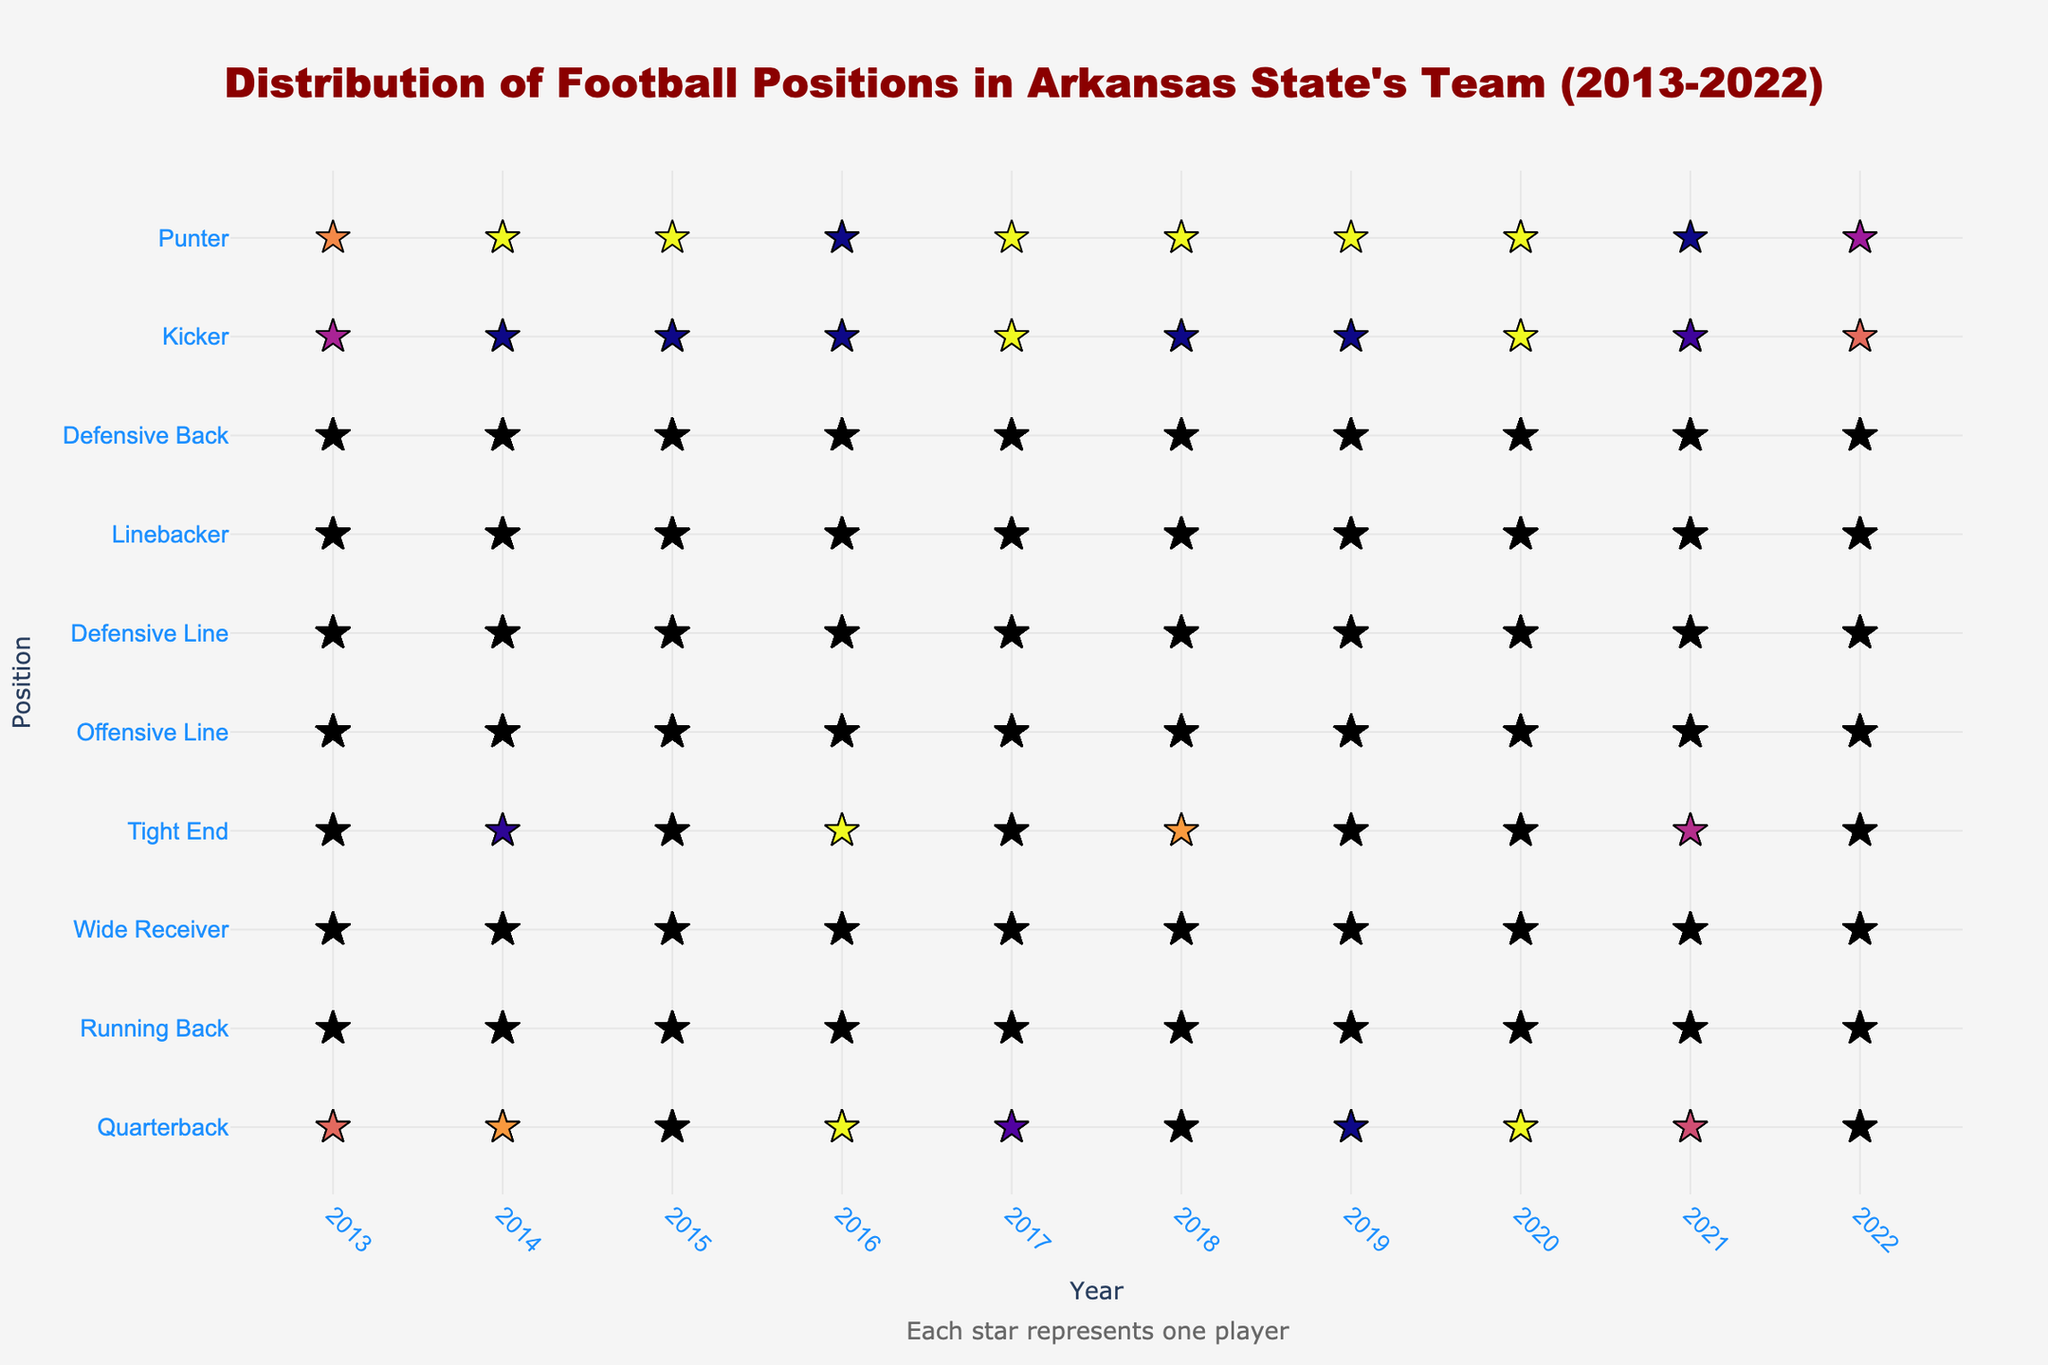What is the title of the plot? The title is usually displayed at the top of the plot. Here, it reads "Distribution of Football Positions in Arkansas State's Team (2013-2022)."
Answer: Distribution of Football Positions in Arkansas State's Team (2013-2022) How many Quarterbacks were there in 2015? To find the number of Quarterbacks in 2015, look for the number of star markers in the 2015 column corresponding to the row labeled "Quarterback."
Answer: 4 Which position had the most players consistently throughout the years? Find the row with the most star markers across all years. The "Offensive Line" position has significantly more markers than any other position consistently.
Answer: Offensive Line How many total players were there in the team in 2014? Sum the number of players for each position in 2014. The values are: 3 + 6 + 9 + 3 + 14 + 11 + 7 + 11 + 2 + 2 = 68.
Answer: 68 Which two positions had the same number of players in 2016? Compare the number of players in each row for 2016. Both the "Quarterback" and "Tight End" positions have 3 players.
Answer: Quarterback and Tight End Did the number of Kickers increase or decrease in 2021 compared to 2013? Compare the number of star markers in the "Kicker" row between 2013 and 2021. In 2013, there were 2 Kickers and in 2021, there were 3 Kickers.
Answer: Increase What can you say about the trends in the "Offensive Line" position over the given years? Observe the number of star markers in the "Offensive Line" row for each year. The number stays the same, alternating between 15 and 14 each year.
Answer: Alternating between 15 and 14 Which positions had an equal number of players in 2020? Look at the number of players for each position in 2020 and find equal values. The "Quarterback" and "Kicker" positions both had 3 players each.
Answer: Quarterback and Kicker Rank the positions by the number of players in 2017, from highest to lowest. Arrange the positions based on the number of star markers in 2017. The counts are: Offensive Line (15), Wide Receiver (10), Defensive Line (10), Defensive Back (10), Linebacker (8), Running Back (5), Tight End (4), Quarterback (3), Kicker (2), Punter (1).
Answer: Offensive Line > Wide Receiver > Defensive Line > Defensive Back > Linebacker > Running Back > Tight End > Quarterback > Kicker > Punter 